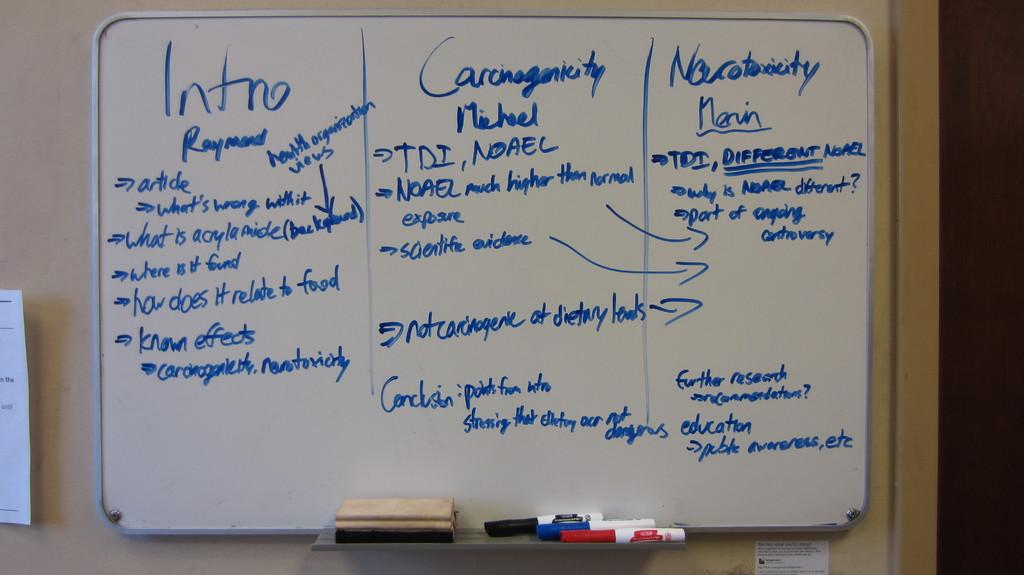<image>
Share a concise interpretation of the image provided. A whiteboard full of ideas discusses neurotoxicity along with an intro and conclusion on it. 